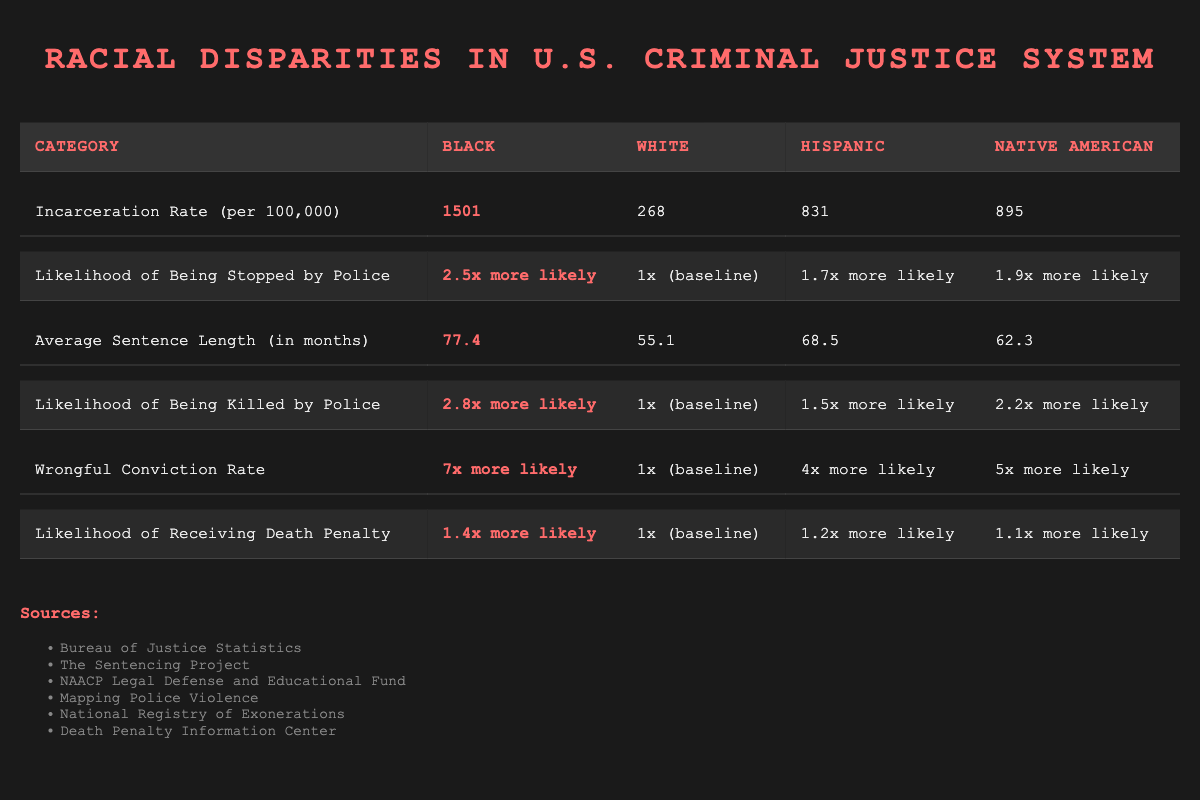What is the incarceration rate for Black individuals? The table shows the row for "Incarceration Rate (per 100,000)" under the Black column, where the data point is listed as 1501. Therefore, this value directly answers the question.
Answer: 1501 How much more likely are Native Americans to be stopped by police compared to the baseline? The table provides a comparison stating that Native Americans are "1.9x more likely" to be stopped by police. This is directly answered by the data present in the "Likelihood of Being Stopped by Police" row under the Native American column.
Answer: 1.9x more likely What is the average sentence length for Hispanic individuals? The "Average Sentence Length (in months)" row provides the average sentence for Hispanic individuals, which is found in the corresponding column. Therefore, it is a straightforward retrieval from the table.
Answer: 68.5 Is the wrongful conviction rate for Black individuals higher than that for White individuals? The table indicates that Black individuals have a "7x more likely" wrongful conviction rate while White individuals have "1x (baseline)." Since seven is greater than one, we conclude that Black individuals indeed have a higher wrongful conviction rate.
Answer: Yes What is the difference in average sentence length between Black and White individuals? The average sentence length for Black individuals is 77.4 months, and for White individuals, it is 55.1 months. To find the difference, we subtract: 77.4 - 55.1 = 22.3 months. This calculation provides the answer.
Answer: 22.3 How does the likelihood of being killed by police vary between Black and Hispanic individuals? The table states that Black individuals are "2.8x more likely" to be killed by police and Hispanic individuals are "1.5x more likely." To find the difference, we compare these two values. Since 2.8 is greater than 1.5, Black individuals have a higher likelihood of being killed by police than Hispanic individuals.
Answer: Black is more likely What is the average incarceration rate of Hispanic and Native American individuals combined? First, we retrieve the incarceration rates: Hispanic is 831 and Native American is 895. We sum these values: 831 + 895 = 1726, and then divide by 2 to find the average: 1726 / 2 = 863. This calculation shows the average incarceration rate across the two groups.
Answer: 863 Are Native Americans less likely to receive the death penalty compared to Black individuals? The table shows that Native Americans are "1.1x more likely" while Black individuals are "1.4x more likely." Since 1.1 is less than 1.4, we can say that Native Americans are indeed less likely to receive the death penalty compared to Black individuals.
Answer: Yes What is the ratio of the likelihood of being stopped by police for Black individuals to that of Hispanic individuals? For Black individuals, the likelihood is "2.5x more likely," and for Hispanic individuals, it is "1.7x more likely." To find the ratio, we divide 2.5 by 1.7, which gives approximately 1.47. Thus, the ratio indicates that Black individuals are about 1.47 times more likely to be stopped than Hispanic individuals.
Answer: 1.47 